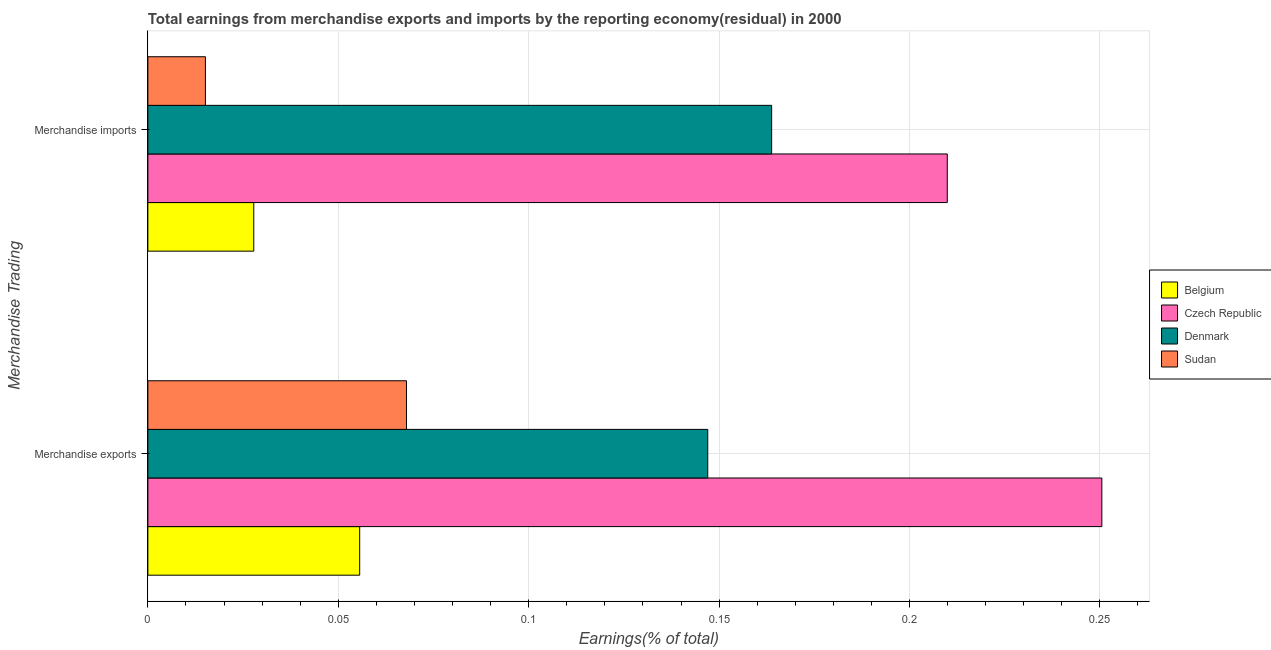How many different coloured bars are there?
Your answer should be compact. 4. Are the number of bars on each tick of the Y-axis equal?
Provide a succinct answer. Yes. How many bars are there on the 2nd tick from the top?
Your answer should be very brief. 4. What is the earnings from merchandise imports in Denmark?
Your answer should be very brief. 0.16. Across all countries, what is the maximum earnings from merchandise imports?
Your answer should be very brief. 0.21. Across all countries, what is the minimum earnings from merchandise exports?
Make the answer very short. 0.06. In which country was the earnings from merchandise imports maximum?
Make the answer very short. Czech Republic. In which country was the earnings from merchandise imports minimum?
Offer a terse response. Sudan. What is the total earnings from merchandise exports in the graph?
Keep it short and to the point. 0.52. What is the difference between the earnings from merchandise imports in Denmark and that in Belgium?
Keep it short and to the point. 0.14. What is the difference between the earnings from merchandise exports in Belgium and the earnings from merchandise imports in Czech Republic?
Offer a very short reply. -0.15. What is the average earnings from merchandise imports per country?
Keep it short and to the point. 0.1. What is the difference between the earnings from merchandise exports and earnings from merchandise imports in Denmark?
Ensure brevity in your answer.  -0.02. What is the ratio of the earnings from merchandise imports in Czech Republic to that in Sudan?
Offer a very short reply. 13.89. Is the earnings from merchandise exports in Sudan less than that in Denmark?
Keep it short and to the point. Yes. In how many countries, is the earnings from merchandise exports greater than the average earnings from merchandise exports taken over all countries?
Ensure brevity in your answer.  2. What does the 1st bar from the top in Merchandise exports represents?
Provide a succinct answer. Sudan. What does the 3rd bar from the bottom in Merchandise exports represents?
Keep it short and to the point. Denmark. How many bars are there?
Provide a short and direct response. 8. Are all the bars in the graph horizontal?
Ensure brevity in your answer.  Yes. How many countries are there in the graph?
Your response must be concise. 4. What is the title of the graph?
Keep it short and to the point. Total earnings from merchandise exports and imports by the reporting economy(residual) in 2000. What is the label or title of the X-axis?
Your response must be concise. Earnings(% of total). What is the label or title of the Y-axis?
Your answer should be very brief. Merchandise Trading. What is the Earnings(% of total) of Belgium in Merchandise exports?
Make the answer very short. 0.06. What is the Earnings(% of total) in Czech Republic in Merchandise exports?
Ensure brevity in your answer.  0.25. What is the Earnings(% of total) of Denmark in Merchandise exports?
Offer a terse response. 0.15. What is the Earnings(% of total) in Sudan in Merchandise exports?
Make the answer very short. 0.07. What is the Earnings(% of total) in Belgium in Merchandise imports?
Provide a short and direct response. 0.03. What is the Earnings(% of total) of Czech Republic in Merchandise imports?
Your response must be concise. 0.21. What is the Earnings(% of total) in Denmark in Merchandise imports?
Offer a very short reply. 0.16. What is the Earnings(% of total) in Sudan in Merchandise imports?
Keep it short and to the point. 0.02. Across all Merchandise Trading, what is the maximum Earnings(% of total) of Belgium?
Provide a short and direct response. 0.06. Across all Merchandise Trading, what is the maximum Earnings(% of total) in Czech Republic?
Provide a short and direct response. 0.25. Across all Merchandise Trading, what is the maximum Earnings(% of total) in Denmark?
Make the answer very short. 0.16. Across all Merchandise Trading, what is the maximum Earnings(% of total) of Sudan?
Your answer should be very brief. 0.07. Across all Merchandise Trading, what is the minimum Earnings(% of total) in Belgium?
Ensure brevity in your answer.  0.03. Across all Merchandise Trading, what is the minimum Earnings(% of total) of Czech Republic?
Provide a short and direct response. 0.21. Across all Merchandise Trading, what is the minimum Earnings(% of total) of Denmark?
Keep it short and to the point. 0.15. Across all Merchandise Trading, what is the minimum Earnings(% of total) in Sudan?
Provide a succinct answer. 0.02. What is the total Earnings(% of total) of Belgium in the graph?
Give a very brief answer. 0.08. What is the total Earnings(% of total) in Czech Republic in the graph?
Make the answer very short. 0.46. What is the total Earnings(% of total) of Denmark in the graph?
Your response must be concise. 0.31. What is the total Earnings(% of total) of Sudan in the graph?
Your answer should be very brief. 0.08. What is the difference between the Earnings(% of total) of Belgium in Merchandise exports and that in Merchandise imports?
Provide a succinct answer. 0.03. What is the difference between the Earnings(% of total) in Czech Republic in Merchandise exports and that in Merchandise imports?
Provide a short and direct response. 0.04. What is the difference between the Earnings(% of total) in Denmark in Merchandise exports and that in Merchandise imports?
Give a very brief answer. -0.02. What is the difference between the Earnings(% of total) in Sudan in Merchandise exports and that in Merchandise imports?
Keep it short and to the point. 0.05. What is the difference between the Earnings(% of total) of Belgium in Merchandise exports and the Earnings(% of total) of Czech Republic in Merchandise imports?
Your answer should be very brief. -0.15. What is the difference between the Earnings(% of total) in Belgium in Merchandise exports and the Earnings(% of total) in Denmark in Merchandise imports?
Your answer should be very brief. -0.11. What is the difference between the Earnings(% of total) of Belgium in Merchandise exports and the Earnings(% of total) of Sudan in Merchandise imports?
Your answer should be compact. 0.04. What is the difference between the Earnings(% of total) of Czech Republic in Merchandise exports and the Earnings(% of total) of Denmark in Merchandise imports?
Your response must be concise. 0.09. What is the difference between the Earnings(% of total) in Czech Republic in Merchandise exports and the Earnings(% of total) in Sudan in Merchandise imports?
Offer a terse response. 0.24. What is the difference between the Earnings(% of total) of Denmark in Merchandise exports and the Earnings(% of total) of Sudan in Merchandise imports?
Your answer should be very brief. 0.13. What is the average Earnings(% of total) of Belgium per Merchandise Trading?
Provide a succinct answer. 0.04. What is the average Earnings(% of total) in Czech Republic per Merchandise Trading?
Provide a short and direct response. 0.23. What is the average Earnings(% of total) of Denmark per Merchandise Trading?
Give a very brief answer. 0.16. What is the average Earnings(% of total) of Sudan per Merchandise Trading?
Provide a succinct answer. 0.04. What is the difference between the Earnings(% of total) of Belgium and Earnings(% of total) of Czech Republic in Merchandise exports?
Your answer should be very brief. -0.19. What is the difference between the Earnings(% of total) of Belgium and Earnings(% of total) of Denmark in Merchandise exports?
Provide a short and direct response. -0.09. What is the difference between the Earnings(% of total) of Belgium and Earnings(% of total) of Sudan in Merchandise exports?
Offer a terse response. -0.01. What is the difference between the Earnings(% of total) of Czech Republic and Earnings(% of total) of Denmark in Merchandise exports?
Offer a very short reply. 0.1. What is the difference between the Earnings(% of total) of Czech Republic and Earnings(% of total) of Sudan in Merchandise exports?
Your response must be concise. 0.18. What is the difference between the Earnings(% of total) of Denmark and Earnings(% of total) of Sudan in Merchandise exports?
Make the answer very short. 0.08. What is the difference between the Earnings(% of total) in Belgium and Earnings(% of total) in Czech Republic in Merchandise imports?
Make the answer very short. -0.18. What is the difference between the Earnings(% of total) of Belgium and Earnings(% of total) of Denmark in Merchandise imports?
Provide a succinct answer. -0.14. What is the difference between the Earnings(% of total) in Belgium and Earnings(% of total) in Sudan in Merchandise imports?
Give a very brief answer. 0.01. What is the difference between the Earnings(% of total) of Czech Republic and Earnings(% of total) of Denmark in Merchandise imports?
Your answer should be very brief. 0.05. What is the difference between the Earnings(% of total) of Czech Republic and Earnings(% of total) of Sudan in Merchandise imports?
Your response must be concise. 0.19. What is the difference between the Earnings(% of total) of Denmark and Earnings(% of total) of Sudan in Merchandise imports?
Keep it short and to the point. 0.15. What is the ratio of the Earnings(% of total) in Belgium in Merchandise exports to that in Merchandise imports?
Ensure brevity in your answer.  2. What is the ratio of the Earnings(% of total) of Czech Republic in Merchandise exports to that in Merchandise imports?
Your answer should be very brief. 1.19. What is the ratio of the Earnings(% of total) of Denmark in Merchandise exports to that in Merchandise imports?
Offer a terse response. 0.9. What is the ratio of the Earnings(% of total) in Sudan in Merchandise exports to that in Merchandise imports?
Your answer should be compact. 4.49. What is the difference between the highest and the second highest Earnings(% of total) of Belgium?
Your response must be concise. 0.03. What is the difference between the highest and the second highest Earnings(% of total) in Czech Republic?
Offer a very short reply. 0.04. What is the difference between the highest and the second highest Earnings(% of total) in Denmark?
Keep it short and to the point. 0.02. What is the difference between the highest and the second highest Earnings(% of total) in Sudan?
Make the answer very short. 0.05. What is the difference between the highest and the lowest Earnings(% of total) in Belgium?
Offer a terse response. 0.03. What is the difference between the highest and the lowest Earnings(% of total) of Czech Republic?
Provide a succinct answer. 0.04. What is the difference between the highest and the lowest Earnings(% of total) of Denmark?
Give a very brief answer. 0.02. What is the difference between the highest and the lowest Earnings(% of total) in Sudan?
Keep it short and to the point. 0.05. 